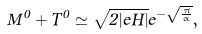Convert formula to latex. <formula><loc_0><loc_0><loc_500><loc_500>M ^ { 0 } + T ^ { 0 } \simeq \sqrt { 2 | e H | } e ^ { - \sqrt { \frac { \pi } { \alpha } } } ,</formula> 